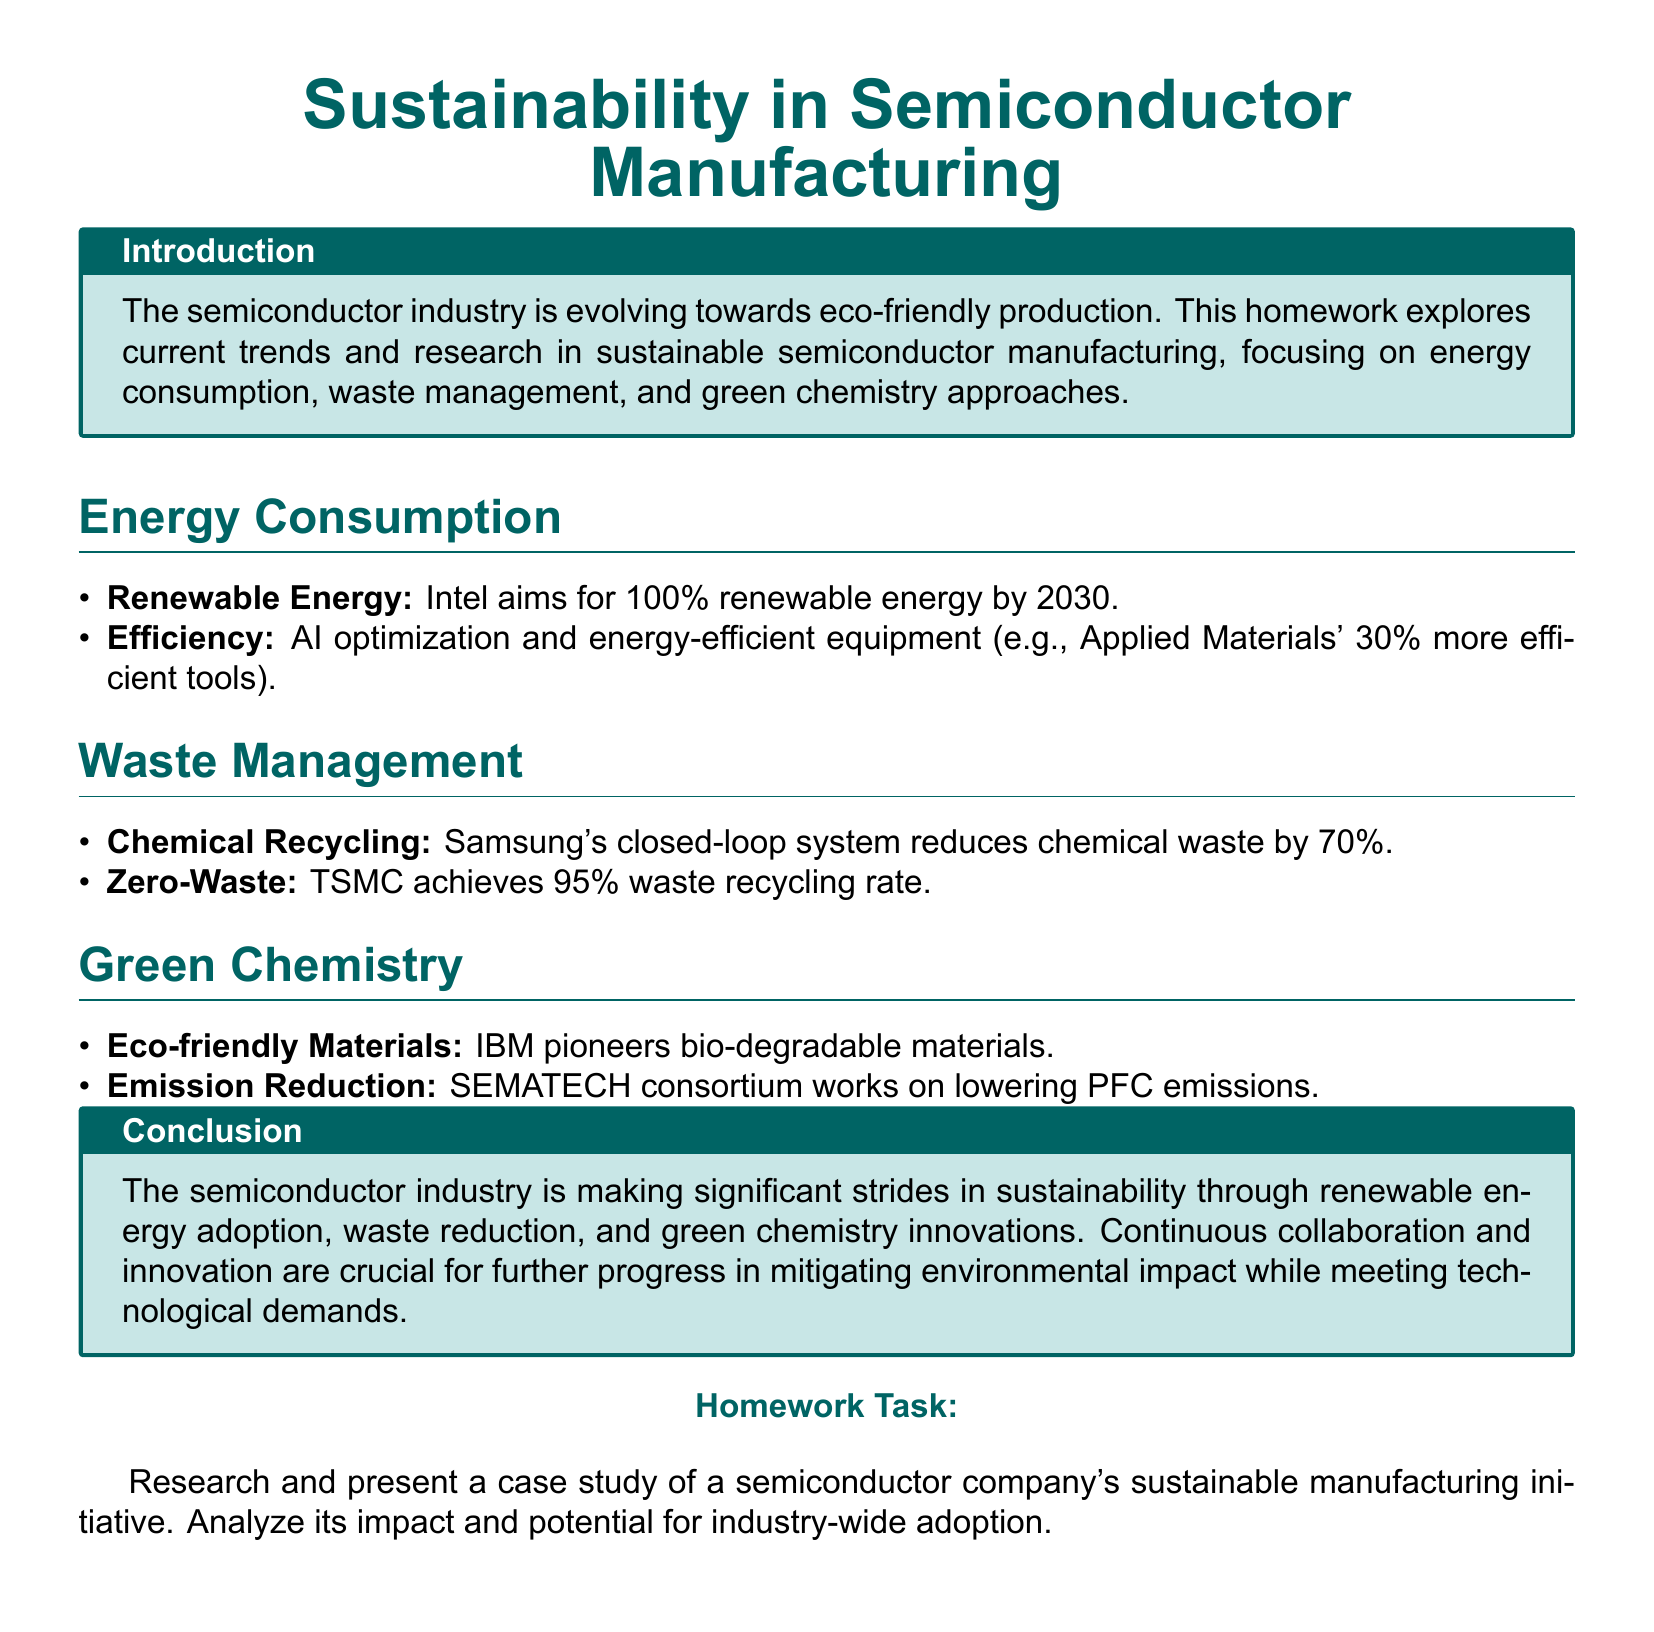What is Intel's renewable energy goal? The document states that Intel aims for 100% renewable energy by 2030.
Answer: 100% renewable energy by 2030 What percentage increase in efficiency do Applied Materials' tools provide? The document notes that Applied Materials' tools are 30% more efficient.
Answer: 30% What is Samsung's achievement in chemical waste reduction? The document mentions that Samsung's closed-loop system reduces chemical waste by 70%.
Answer: 70% What waste recycling rate does TSMC achieve? The document indicates that TSMC achieves a 95% waste recycling rate.
Answer: 95% Who pioneers biodegradable materials in the semiconductor industry? According to the document, IBM pioneers biodegradable materials.
Answer: IBM What consortium works on lowering PFC emissions? The document identifies the SEMATECH consortium as working on lowering PFC emissions.
Answer: SEMATECH What sustainable manufacturing case study task is presented? The document describes the homework task as researching and presenting a case study of a semiconductor company's sustainable manufacturing initiative.
Answer: Case study of a semiconductor company's initiative What is emphasized as crucial for further progress in sustainability? The document highlights that continuous collaboration and innovation are crucial for further progress.
Answer: Continuous collaboration and innovation What is the focus of this homework? The document focuses on current trends and research in sustainable semiconductor manufacturing.
Answer: Current trends and research in sustainable semiconductor manufacturing 